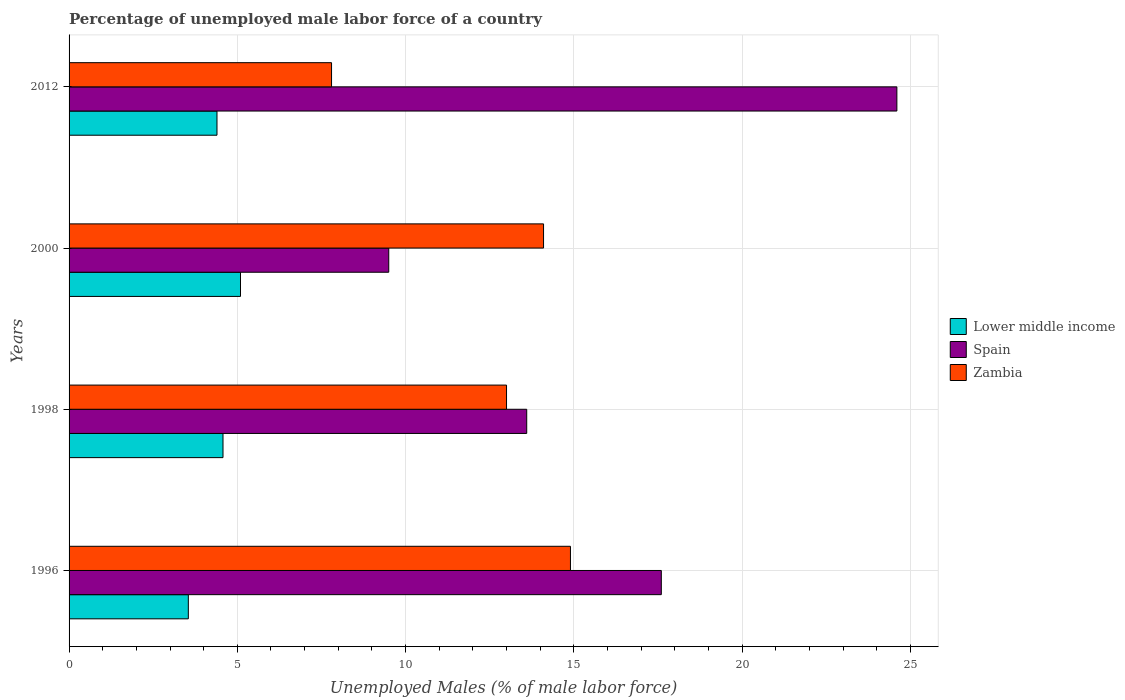Are the number of bars per tick equal to the number of legend labels?
Offer a very short reply. Yes. How many bars are there on the 2nd tick from the bottom?
Ensure brevity in your answer.  3. What is the label of the 2nd group of bars from the top?
Provide a short and direct response. 2000. In how many cases, is the number of bars for a given year not equal to the number of legend labels?
Your answer should be compact. 0. Across all years, what is the maximum percentage of unemployed male labor force in Lower middle income?
Keep it short and to the point. 5.09. Across all years, what is the minimum percentage of unemployed male labor force in Lower middle income?
Keep it short and to the point. 3.54. In which year was the percentage of unemployed male labor force in Lower middle income minimum?
Your response must be concise. 1996. What is the total percentage of unemployed male labor force in Lower middle income in the graph?
Offer a very short reply. 17.61. What is the difference between the percentage of unemployed male labor force in Spain in 2000 and that in 2012?
Make the answer very short. -15.1. What is the difference between the percentage of unemployed male labor force in Spain in 1996 and the percentage of unemployed male labor force in Zambia in 1998?
Give a very brief answer. 4.6. What is the average percentage of unemployed male labor force in Lower middle income per year?
Your answer should be very brief. 4.4. In the year 2012, what is the difference between the percentage of unemployed male labor force in Spain and percentage of unemployed male labor force in Lower middle income?
Give a very brief answer. 20.2. What is the ratio of the percentage of unemployed male labor force in Zambia in 1996 to that in 2012?
Keep it short and to the point. 1.91. Is the percentage of unemployed male labor force in Zambia in 1996 less than that in 1998?
Your answer should be very brief. No. Is the difference between the percentage of unemployed male labor force in Spain in 1998 and 2012 greater than the difference between the percentage of unemployed male labor force in Lower middle income in 1998 and 2012?
Make the answer very short. No. What is the difference between the highest and the second highest percentage of unemployed male labor force in Lower middle income?
Provide a short and direct response. 0.52. What is the difference between the highest and the lowest percentage of unemployed male labor force in Zambia?
Give a very brief answer. 7.1. Is the sum of the percentage of unemployed male labor force in Zambia in 2000 and 2012 greater than the maximum percentage of unemployed male labor force in Spain across all years?
Offer a terse response. No. What does the 3rd bar from the top in 2012 represents?
Provide a succinct answer. Lower middle income. What does the 3rd bar from the bottom in 1998 represents?
Offer a very short reply. Zambia. Is it the case that in every year, the sum of the percentage of unemployed male labor force in Zambia and percentage of unemployed male labor force in Lower middle income is greater than the percentage of unemployed male labor force in Spain?
Provide a short and direct response. No. How many bars are there?
Ensure brevity in your answer.  12. Are all the bars in the graph horizontal?
Your answer should be compact. Yes. Does the graph contain grids?
Give a very brief answer. Yes. Where does the legend appear in the graph?
Your answer should be very brief. Center right. How are the legend labels stacked?
Make the answer very short. Vertical. What is the title of the graph?
Ensure brevity in your answer.  Percentage of unemployed male labor force of a country. What is the label or title of the X-axis?
Provide a short and direct response. Unemployed Males (% of male labor force). What is the label or title of the Y-axis?
Make the answer very short. Years. What is the Unemployed Males (% of male labor force) of Lower middle income in 1996?
Your response must be concise. 3.54. What is the Unemployed Males (% of male labor force) in Spain in 1996?
Offer a very short reply. 17.6. What is the Unemployed Males (% of male labor force) in Zambia in 1996?
Provide a short and direct response. 14.9. What is the Unemployed Males (% of male labor force) in Lower middle income in 1998?
Provide a succinct answer. 4.57. What is the Unemployed Males (% of male labor force) in Spain in 1998?
Provide a short and direct response. 13.6. What is the Unemployed Males (% of male labor force) of Lower middle income in 2000?
Make the answer very short. 5.09. What is the Unemployed Males (% of male labor force) in Spain in 2000?
Keep it short and to the point. 9.5. What is the Unemployed Males (% of male labor force) of Zambia in 2000?
Offer a terse response. 14.1. What is the Unemployed Males (% of male labor force) in Lower middle income in 2012?
Offer a very short reply. 4.4. What is the Unemployed Males (% of male labor force) of Spain in 2012?
Offer a terse response. 24.6. What is the Unemployed Males (% of male labor force) of Zambia in 2012?
Provide a short and direct response. 7.8. Across all years, what is the maximum Unemployed Males (% of male labor force) in Lower middle income?
Make the answer very short. 5.09. Across all years, what is the maximum Unemployed Males (% of male labor force) of Spain?
Make the answer very short. 24.6. Across all years, what is the maximum Unemployed Males (% of male labor force) in Zambia?
Make the answer very short. 14.9. Across all years, what is the minimum Unemployed Males (% of male labor force) of Lower middle income?
Ensure brevity in your answer.  3.54. Across all years, what is the minimum Unemployed Males (% of male labor force) of Spain?
Your answer should be very brief. 9.5. Across all years, what is the minimum Unemployed Males (% of male labor force) in Zambia?
Offer a very short reply. 7.8. What is the total Unemployed Males (% of male labor force) in Lower middle income in the graph?
Provide a succinct answer. 17.61. What is the total Unemployed Males (% of male labor force) in Spain in the graph?
Provide a short and direct response. 65.3. What is the total Unemployed Males (% of male labor force) in Zambia in the graph?
Ensure brevity in your answer.  49.8. What is the difference between the Unemployed Males (% of male labor force) of Lower middle income in 1996 and that in 1998?
Your response must be concise. -1.03. What is the difference between the Unemployed Males (% of male labor force) of Zambia in 1996 and that in 1998?
Provide a succinct answer. 1.9. What is the difference between the Unemployed Males (% of male labor force) of Lower middle income in 1996 and that in 2000?
Ensure brevity in your answer.  -1.55. What is the difference between the Unemployed Males (% of male labor force) in Spain in 1996 and that in 2000?
Provide a succinct answer. 8.1. What is the difference between the Unemployed Males (% of male labor force) in Zambia in 1996 and that in 2000?
Provide a short and direct response. 0.8. What is the difference between the Unemployed Males (% of male labor force) of Lower middle income in 1996 and that in 2012?
Your response must be concise. -0.85. What is the difference between the Unemployed Males (% of male labor force) in Zambia in 1996 and that in 2012?
Offer a terse response. 7.1. What is the difference between the Unemployed Males (% of male labor force) in Lower middle income in 1998 and that in 2000?
Offer a very short reply. -0.52. What is the difference between the Unemployed Males (% of male labor force) of Spain in 1998 and that in 2000?
Make the answer very short. 4.1. What is the difference between the Unemployed Males (% of male labor force) of Lower middle income in 1998 and that in 2012?
Ensure brevity in your answer.  0.18. What is the difference between the Unemployed Males (% of male labor force) of Spain in 1998 and that in 2012?
Offer a very short reply. -11. What is the difference between the Unemployed Males (% of male labor force) in Zambia in 1998 and that in 2012?
Ensure brevity in your answer.  5.2. What is the difference between the Unemployed Males (% of male labor force) in Lower middle income in 2000 and that in 2012?
Provide a short and direct response. 0.7. What is the difference between the Unemployed Males (% of male labor force) of Spain in 2000 and that in 2012?
Provide a succinct answer. -15.1. What is the difference between the Unemployed Males (% of male labor force) in Zambia in 2000 and that in 2012?
Ensure brevity in your answer.  6.3. What is the difference between the Unemployed Males (% of male labor force) of Lower middle income in 1996 and the Unemployed Males (% of male labor force) of Spain in 1998?
Your answer should be very brief. -10.06. What is the difference between the Unemployed Males (% of male labor force) in Lower middle income in 1996 and the Unemployed Males (% of male labor force) in Zambia in 1998?
Provide a short and direct response. -9.46. What is the difference between the Unemployed Males (% of male labor force) of Lower middle income in 1996 and the Unemployed Males (% of male labor force) of Spain in 2000?
Your answer should be very brief. -5.96. What is the difference between the Unemployed Males (% of male labor force) of Lower middle income in 1996 and the Unemployed Males (% of male labor force) of Zambia in 2000?
Provide a short and direct response. -10.56. What is the difference between the Unemployed Males (% of male labor force) in Spain in 1996 and the Unemployed Males (% of male labor force) in Zambia in 2000?
Provide a succinct answer. 3.5. What is the difference between the Unemployed Males (% of male labor force) of Lower middle income in 1996 and the Unemployed Males (% of male labor force) of Spain in 2012?
Keep it short and to the point. -21.06. What is the difference between the Unemployed Males (% of male labor force) in Lower middle income in 1996 and the Unemployed Males (% of male labor force) in Zambia in 2012?
Your answer should be very brief. -4.26. What is the difference between the Unemployed Males (% of male labor force) in Spain in 1996 and the Unemployed Males (% of male labor force) in Zambia in 2012?
Your answer should be very brief. 9.8. What is the difference between the Unemployed Males (% of male labor force) of Lower middle income in 1998 and the Unemployed Males (% of male labor force) of Spain in 2000?
Make the answer very short. -4.93. What is the difference between the Unemployed Males (% of male labor force) in Lower middle income in 1998 and the Unemployed Males (% of male labor force) in Zambia in 2000?
Your response must be concise. -9.53. What is the difference between the Unemployed Males (% of male labor force) in Lower middle income in 1998 and the Unemployed Males (% of male labor force) in Spain in 2012?
Your answer should be very brief. -20.03. What is the difference between the Unemployed Males (% of male labor force) of Lower middle income in 1998 and the Unemployed Males (% of male labor force) of Zambia in 2012?
Make the answer very short. -3.23. What is the difference between the Unemployed Males (% of male labor force) in Lower middle income in 2000 and the Unemployed Males (% of male labor force) in Spain in 2012?
Your response must be concise. -19.51. What is the difference between the Unemployed Males (% of male labor force) in Lower middle income in 2000 and the Unemployed Males (% of male labor force) in Zambia in 2012?
Offer a terse response. -2.71. What is the average Unemployed Males (% of male labor force) in Lower middle income per year?
Give a very brief answer. 4.4. What is the average Unemployed Males (% of male labor force) of Spain per year?
Your answer should be very brief. 16.32. What is the average Unemployed Males (% of male labor force) in Zambia per year?
Give a very brief answer. 12.45. In the year 1996, what is the difference between the Unemployed Males (% of male labor force) of Lower middle income and Unemployed Males (% of male labor force) of Spain?
Make the answer very short. -14.06. In the year 1996, what is the difference between the Unemployed Males (% of male labor force) in Lower middle income and Unemployed Males (% of male labor force) in Zambia?
Give a very brief answer. -11.36. In the year 1996, what is the difference between the Unemployed Males (% of male labor force) in Spain and Unemployed Males (% of male labor force) in Zambia?
Offer a terse response. 2.7. In the year 1998, what is the difference between the Unemployed Males (% of male labor force) in Lower middle income and Unemployed Males (% of male labor force) in Spain?
Provide a succinct answer. -9.03. In the year 1998, what is the difference between the Unemployed Males (% of male labor force) in Lower middle income and Unemployed Males (% of male labor force) in Zambia?
Your answer should be compact. -8.43. In the year 2000, what is the difference between the Unemployed Males (% of male labor force) in Lower middle income and Unemployed Males (% of male labor force) in Spain?
Offer a terse response. -4.41. In the year 2000, what is the difference between the Unemployed Males (% of male labor force) of Lower middle income and Unemployed Males (% of male labor force) of Zambia?
Provide a short and direct response. -9.01. In the year 2012, what is the difference between the Unemployed Males (% of male labor force) of Lower middle income and Unemployed Males (% of male labor force) of Spain?
Offer a terse response. -20.2. In the year 2012, what is the difference between the Unemployed Males (% of male labor force) of Lower middle income and Unemployed Males (% of male labor force) of Zambia?
Make the answer very short. -3.4. In the year 2012, what is the difference between the Unemployed Males (% of male labor force) in Spain and Unemployed Males (% of male labor force) in Zambia?
Ensure brevity in your answer.  16.8. What is the ratio of the Unemployed Males (% of male labor force) of Lower middle income in 1996 to that in 1998?
Provide a short and direct response. 0.77. What is the ratio of the Unemployed Males (% of male labor force) of Spain in 1996 to that in 1998?
Your answer should be compact. 1.29. What is the ratio of the Unemployed Males (% of male labor force) in Zambia in 1996 to that in 1998?
Your answer should be very brief. 1.15. What is the ratio of the Unemployed Males (% of male labor force) in Lower middle income in 1996 to that in 2000?
Offer a terse response. 0.7. What is the ratio of the Unemployed Males (% of male labor force) in Spain in 1996 to that in 2000?
Provide a succinct answer. 1.85. What is the ratio of the Unemployed Males (% of male labor force) in Zambia in 1996 to that in 2000?
Ensure brevity in your answer.  1.06. What is the ratio of the Unemployed Males (% of male labor force) of Lower middle income in 1996 to that in 2012?
Your answer should be compact. 0.81. What is the ratio of the Unemployed Males (% of male labor force) of Spain in 1996 to that in 2012?
Keep it short and to the point. 0.72. What is the ratio of the Unemployed Males (% of male labor force) of Zambia in 1996 to that in 2012?
Offer a very short reply. 1.91. What is the ratio of the Unemployed Males (% of male labor force) of Lower middle income in 1998 to that in 2000?
Provide a short and direct response. 0.9. What is the ratio of the Unemployed Males (% of male labor force) of Spain in 1998 to that in 2000?
Give a very brief answer. 1.43. What is the ratio of the Unemployed Males (% of male labor force) of Zambia in 1998 to that in 2000?
Your answer should be compact. 0.92. What is the ratio of the Unemployed Males (% of male labor force) of Lower middle income in 1998 to that in 2012?
Offer a terse response. 1.04. What is the ratio of the Unemployed Males (% of male labor force) of Spain in 1998 to that in 2012?
Ensure brevity in your answer.  0.55. What is the ratio of the Unemployed Males (% of male labor force) in Zambia in 1998 to that in 2012?
Make the answer very short. 1.67. What is the ratio of the Unemployed Males (% of male labor force) of Lower middle income in 2000 to that in 2012?
Make the answer very short. 1.16. What is the ratio of the Unemployed Males (% of male labor force) in Spain in 2000 to that in 2012?
Offer a very short reply. 0.39. What is the ratio of the Unemployed Males (% of male labor force) of Zambia in 2000 to that in 2012?
Your answer should be very brief. 1.81. What is the difference between the highest and the second highest Unemployed Males (% of male labor force) of Lower middle income?
Give a very brief answer. 0.52. What is the difference between the highest and the lowest Unemployed Males (% of male labor force) of Lower middle income?
Provide a succinct answer. 1.55. What is the difference between the highest and the lowest Unemployed Males (% of male labor force) in Zambia?
Your answer should be very brief. 7.1. 